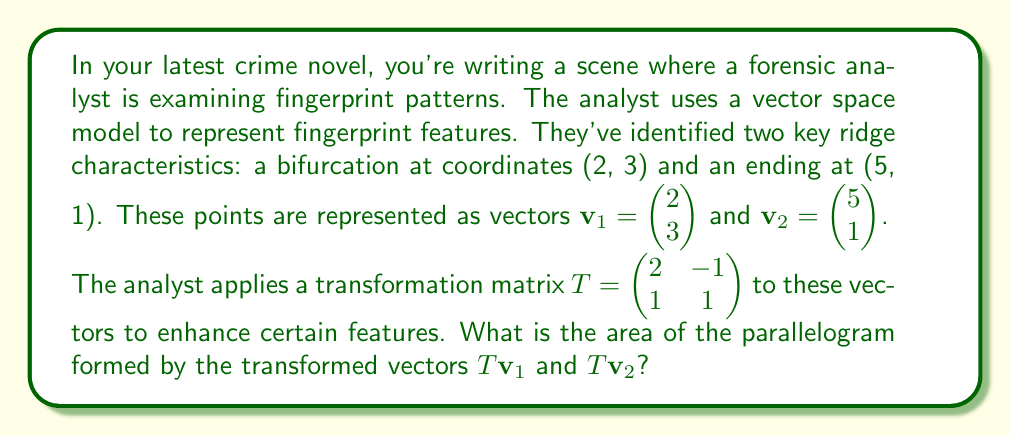Give your solution to this math problem. Let's approach this step-by-step:

1) First, we need to apply the transformation matrix $T$ to both vectors $\mathbf{v}_1$ and $\mathbf{v}_2$.

   For $\mathbf{v}_1$:
   $$T\mathbf{v}_1 = \begin{pmatrix} 2 & -1 \\ 1 & 1 \end{pmatrix} \begin{pmatrix} 2 \\ 3 \end{pmatrix} = \begin{pmatrix} 2(2) + (-1)(3) \\ 1(2) + 1(3) \end{pmatrix} = \begin{pmatrix} 1 \\ 5 \end{pmatrix}$$

   For $\mathbf{v}_2$:
   $$T\mathbf{v}_2 = \begin{pmatrix} 2 & -1 \\ 1 & 1 \end{pmatrix} \begin{pmatrix} 5 \\ 1 \end{pmatrix} = \begin{pmatrix} 2(5) + (-1)(1) \\ 1(5) + 1(1) \end{pmatrix} = \begin{pmatrix} 9 \\ 6 \end{pmatrix}$$

2) Now we have two new vectors: $T\mathbf{v}_1 = \begin{pmatrix} 1 \\ 5 \end{pmatrix}$ and $T\mathbf{v}_2 = \begin{pmatrix} 9 \\ 6 \end{pmatrix}$.

3) To find the area of the parallelogram formed by these vectors, we can use the magnitude of the cross product. In 2D, this is equivalent to the determinant of the matrix formed by these vectors:

   $$\text{Area} = \left|\det\begin{pmatrix} 1 & 9 \\ 5 & 6 \end{pmatrix}\right|$$

4) Calculate the determinant:
   $$\det\begin{pmatrix} 1 & 9 \\ 5 & 6 \end{pmatrix} = 1(6) - 9(5) = 6 - 45 = -39$$

5) Take the absolute value:
   $$|\det\begin{pmatrix} 1 & 9 \\ 5 & 6 \end{pmatrix}| = |-39| = 39$$

Therefore, the area of the parallelogram formed by the transformed vectors is 39 square units.
Answer: 39 square units 